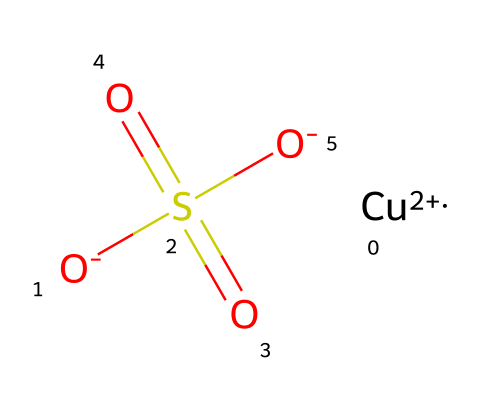how many atoms are in this molecule? The chemical consists of one copper atom (Cu), four oxygen atoms (O), and one sulfur atom (S), totaling six atoms.
Answer: six what type of chemical is represented here? This structure represents an electrolyte, as it contains ions that can dissociate in solution, specifically copper sulfate.
Answer: electrolyte which elements are present in the molecule? The elements in this chemical are copper (Cu), oxygen (O), sulfur (S).
Answer: copper, oxygen, sulfur what is the oxidation state of copper in this compound? Copper is in a +2 oxidation state in this compound, as indicated by the notation [Cu+2] in the SMILES representation.
Answer: +2 how many sulfate groups are in the structure? The molecule contains one sulfate group, which is represented by the structure S(=O)(=O)[O-].
Answer: one what happens to copper sulfate in water? Copper sulfate dissociates into copper ions (Cu²⁺) and sulfate ions (SO₄²⁻) when dissolved in water, indicating its behavior as an electrolyte.
Answer: dissociates what part of the compound contributes to its blue color in patinas? The copper ions (Cu²⁺) in the compound are primarily responsible for the characteristic blue color observed in patinas.
Answer: copper ions 